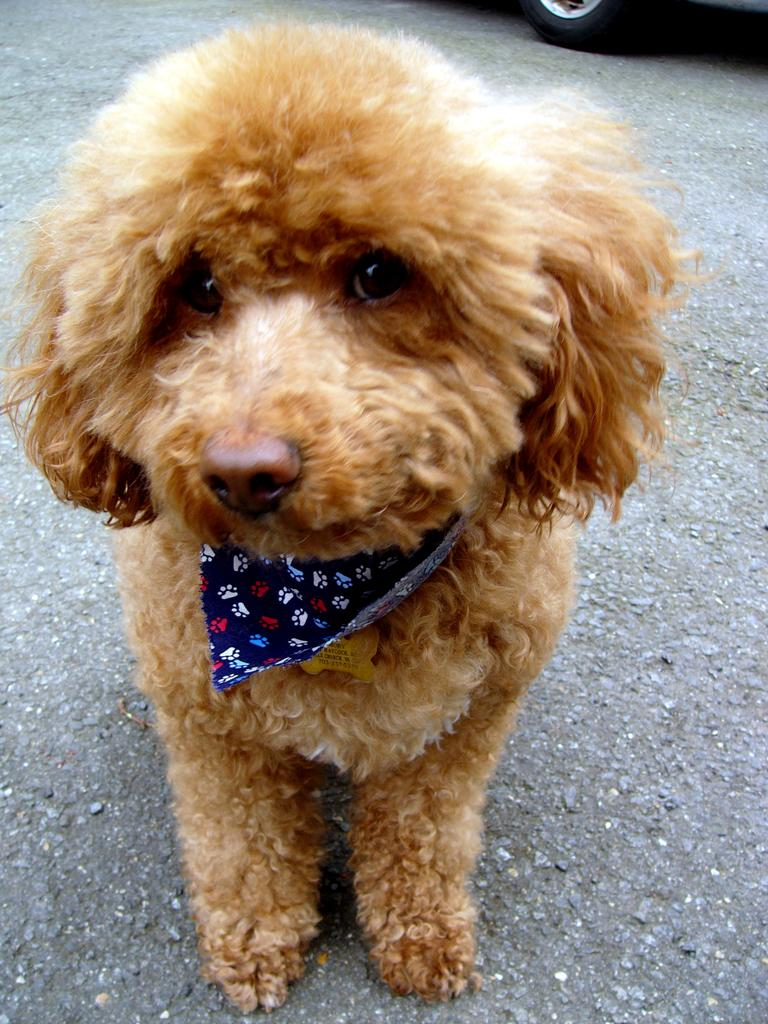What type of animal is in the image? There is a dog in the image. What is the dog doing in the image? The dog is standing on the ground. What is the dog wearing in the image? The dog is wearing an object. What can be seen in the background of the image? There is a vehicle in the background of the image. What type of vegetable is the dog holding in the image? There is no vegetable present in the image; the dog is wearing an object. Can you see a table in the image? There is no table visible in the image. 